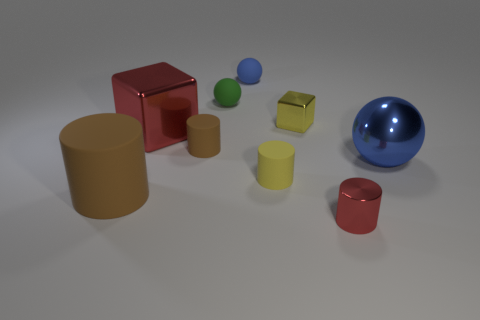Subtract 1 cylinders. How many cylinders are left? 3 Add 1 large gray matte balls. How many objects exist? 10 Subtract all cubes. How many objects are left? 7 Add 9 tiny green objects. How many tiny green objects are left? 10 Add 4 tiny green balls. How many tiny green balls exist? 5 Subtract 0 purple cylinders. How many objects are left? 9 Subtract all large green rubber things. Subtract all tiny balls. How many objects are left? 7 